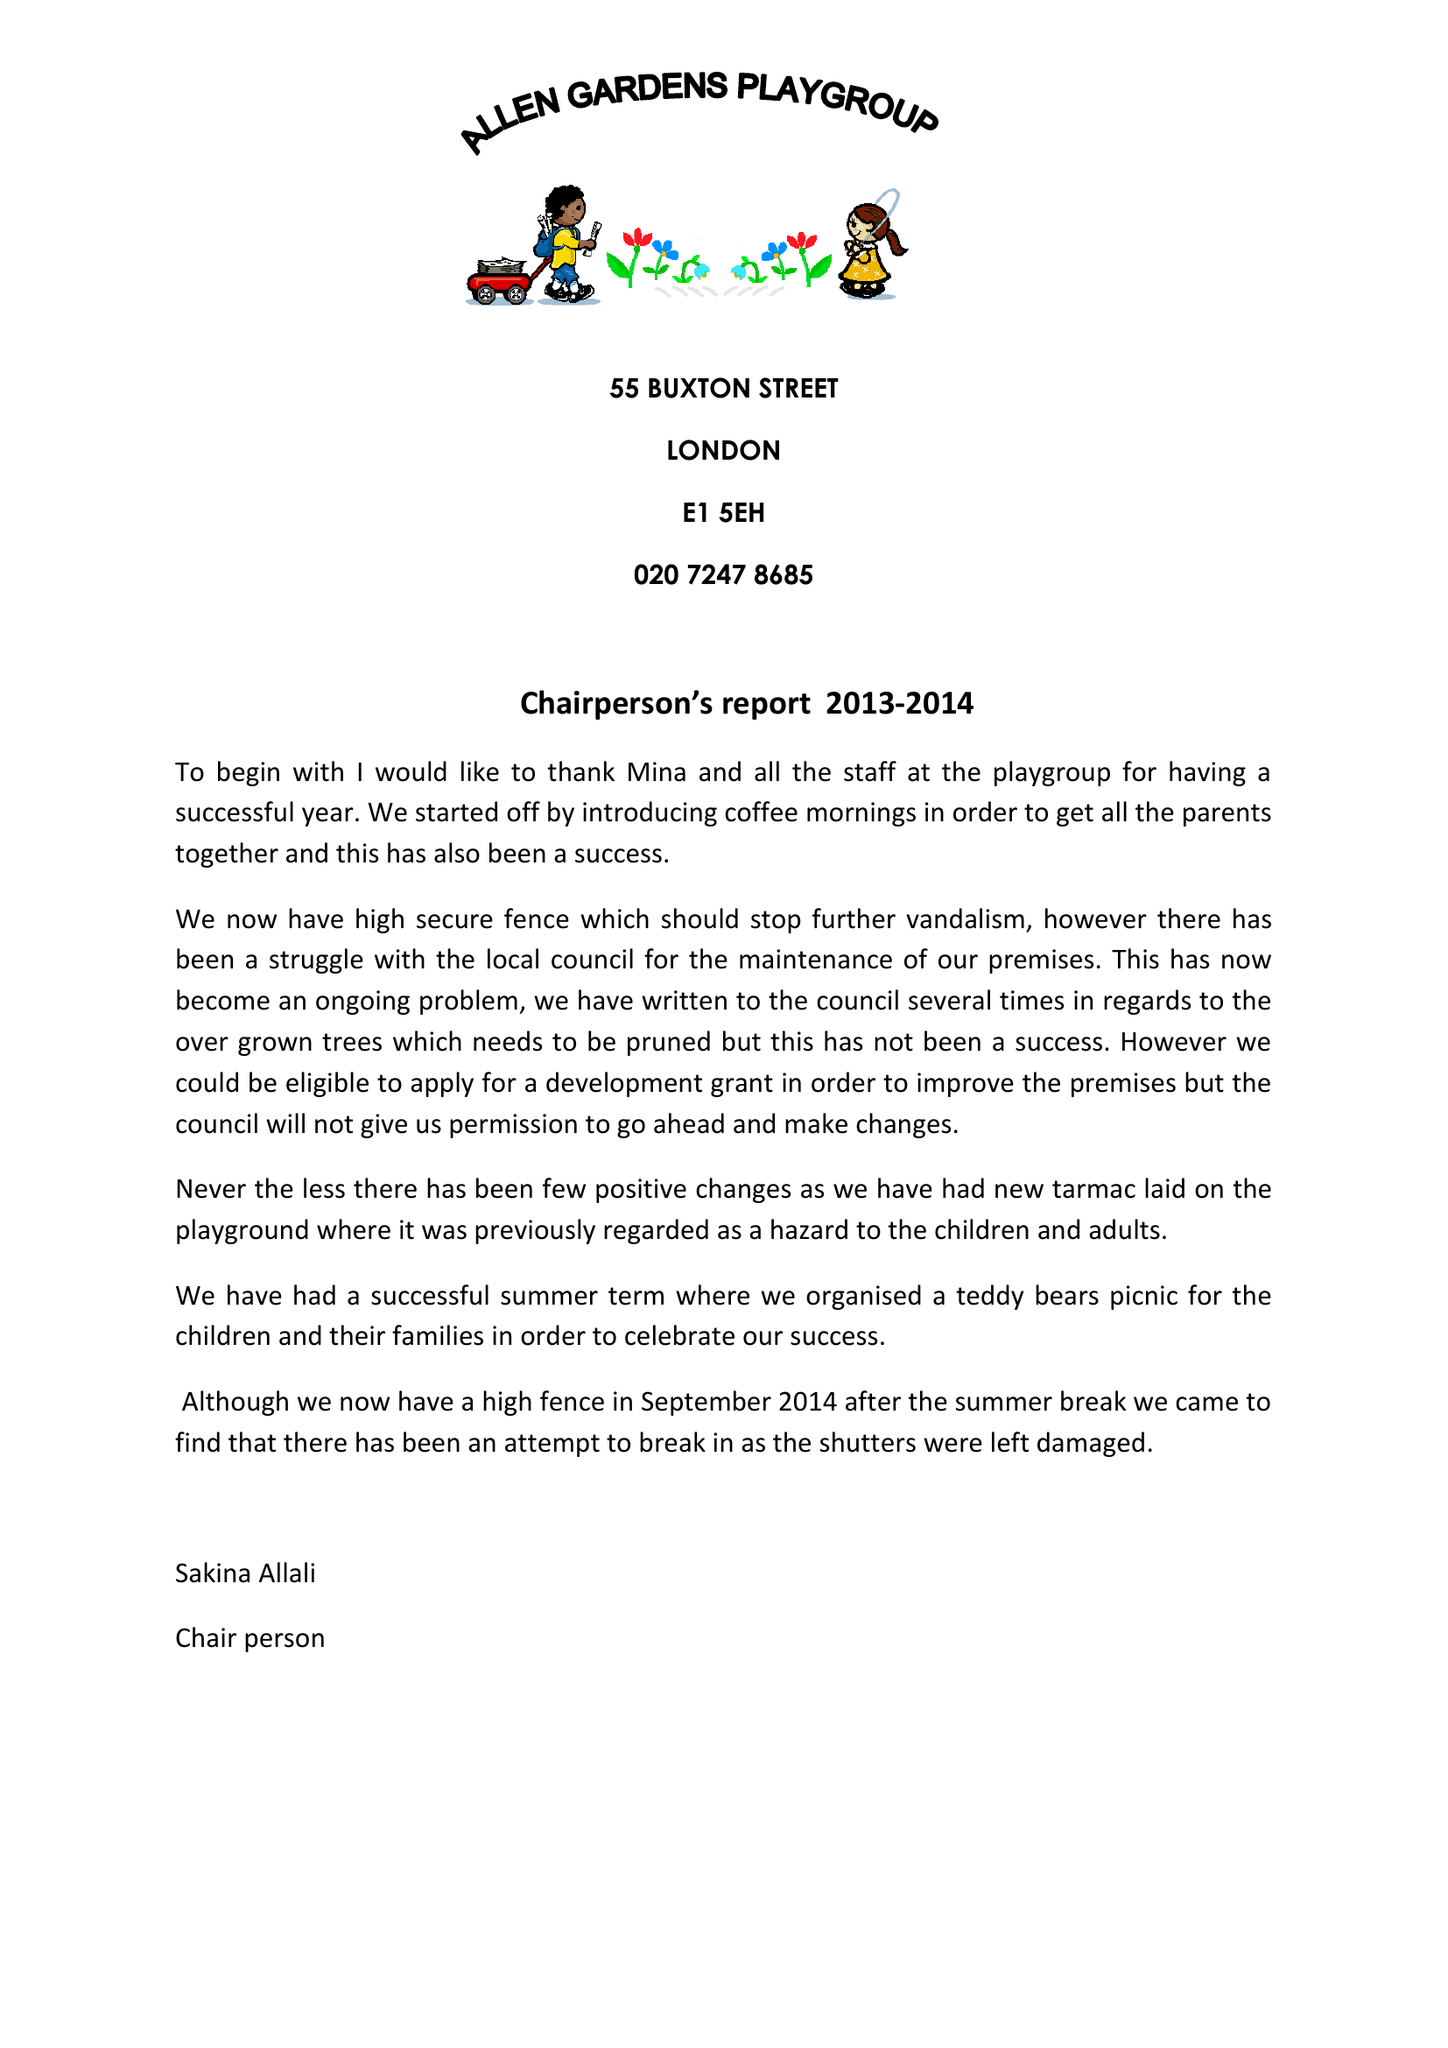What is the value for the address__postcode?
Answer the question using a single word or phrase. E1 5EH 